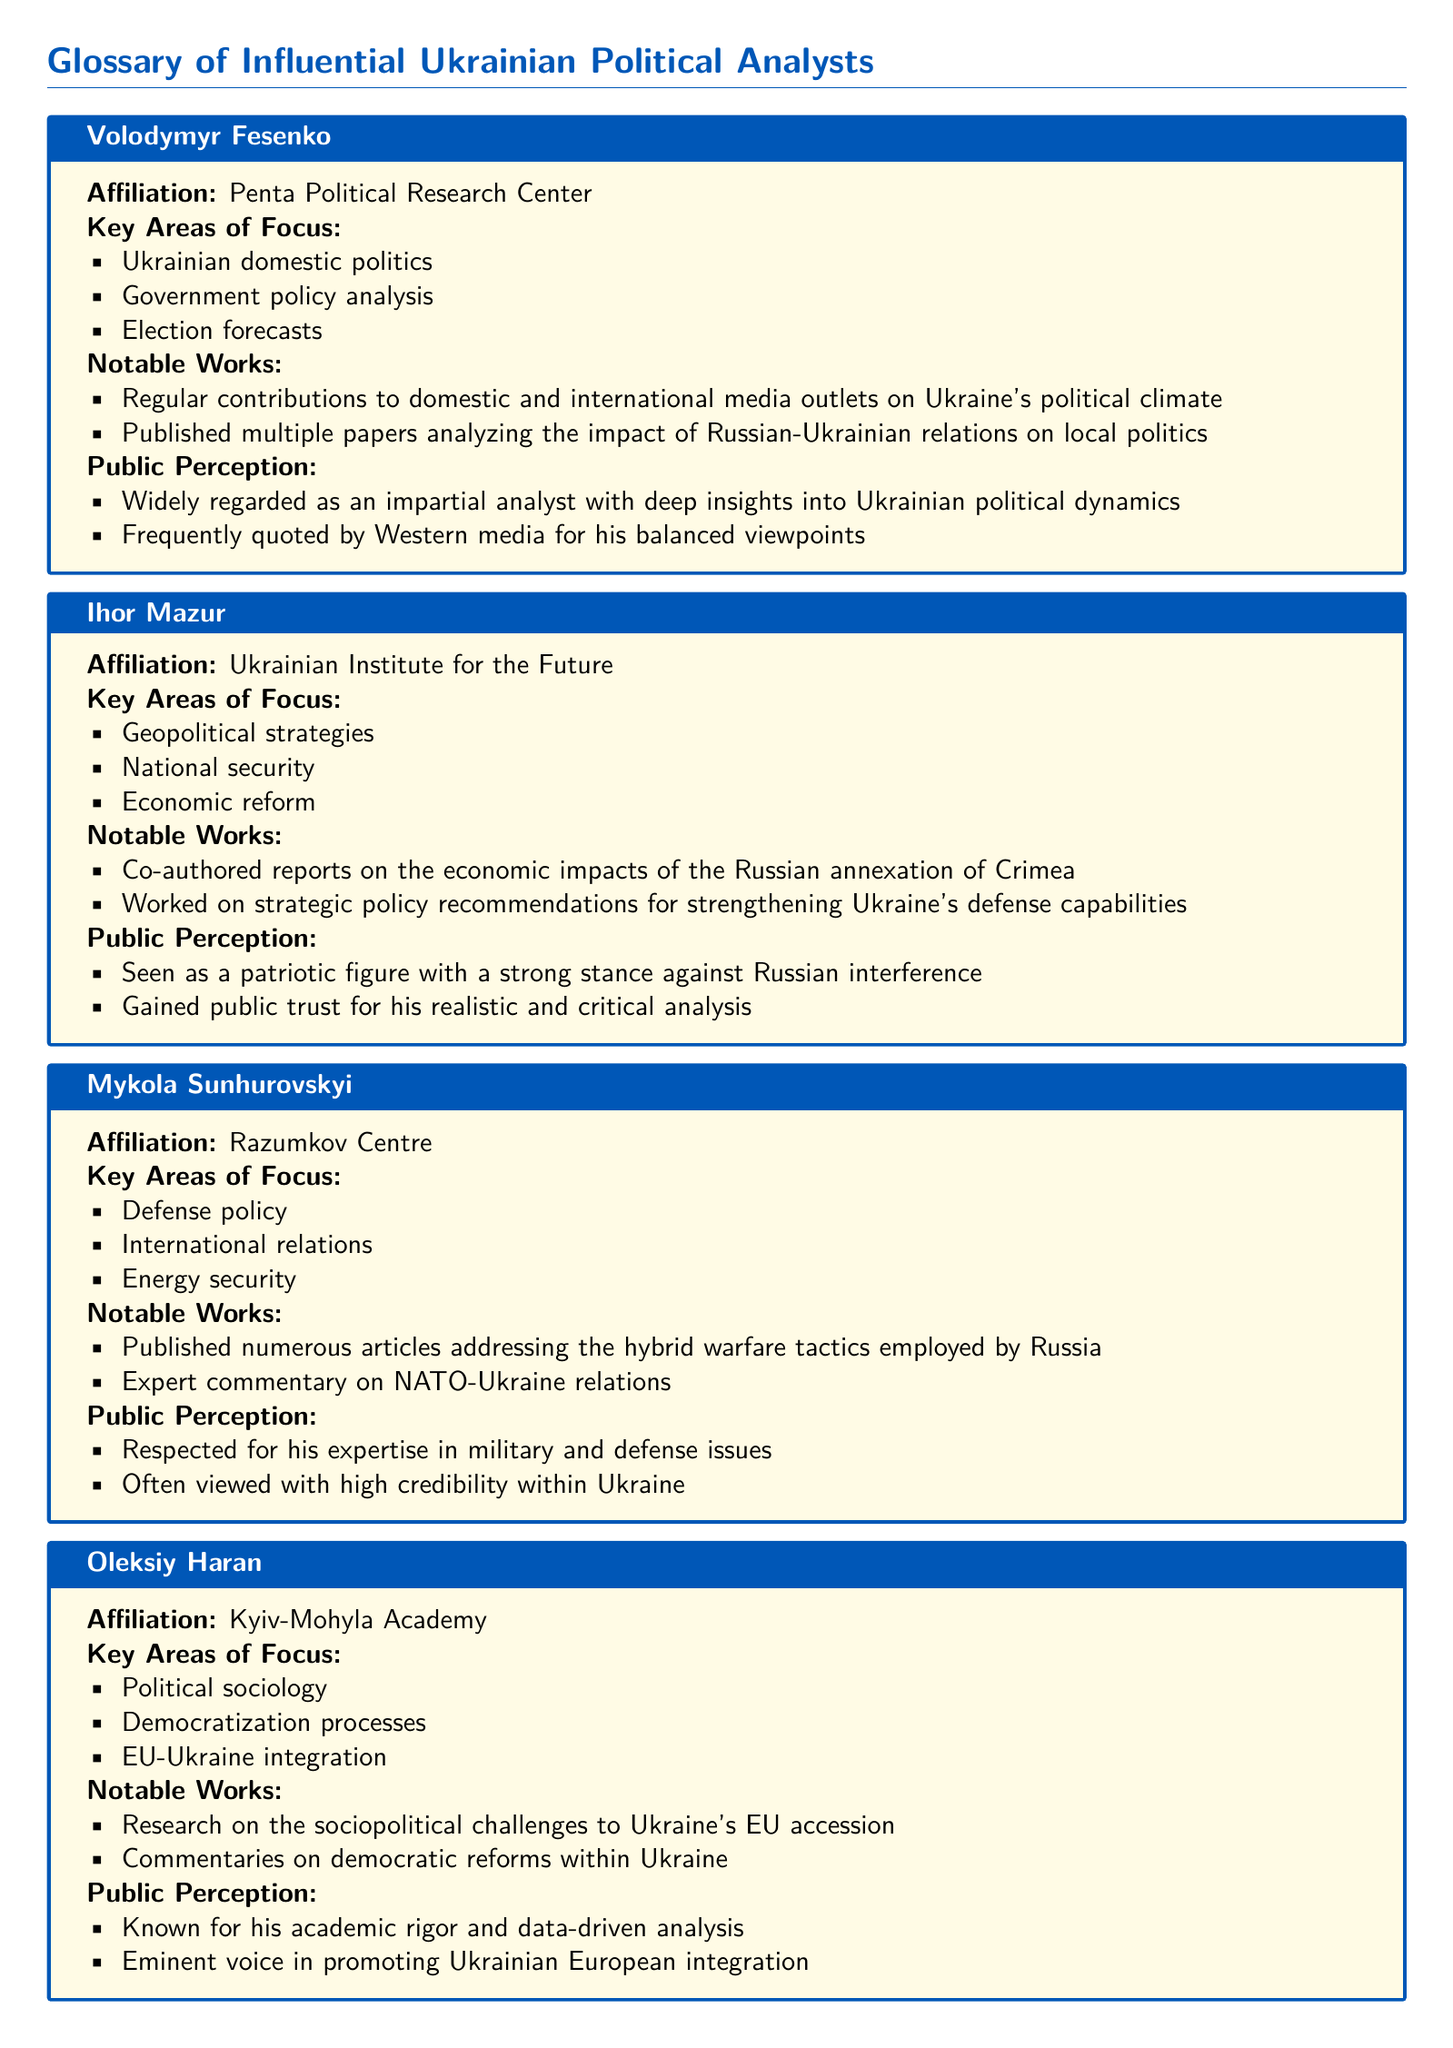What is Mikhail Borisovich Pogrebinsky's affiliation? His affiliation is mentioned in the document as Kyiv Center of Political Studies and Conflictology.
Answer: Kyiv Center of Political Studies and Conflictology What key area of focus is associated with Ihor Mazur? The document lists his key areas of focus, one of which is national security.
Answer: National security Which analyst is known for their work on EU-Ukraine integration? The document highlights Oleksiy Haran's focus areas, one of which is EU-Ukraine integration.
Answer: Oleksiy Haran What notable work is linked to Volodymyr Fesenko? The document states that he has published multiple papers analyzing the impact of Russian-Ukrainian relations on local politics.
Answer: Multiple papers analyzing the impact of Russian-Ukrainian relations on local politics What is the public perception of Mikhail Borisovich Pogrebinsky? The document mentions that he is criticized by many Ukrainians for his perceived pro-Russian bias.
Answer: Criticized for his perceived pro-Russian bias How is Tetiana Sydorchuk regarded in terms of European affairs? She is highly regarded for her in-depth knowledge of European affairs, according to the document.
Answer: Highly regarded What aspect of military issues does Mykola Sunhurovskyi focus on? The document specifies that he focuses on defense policy.
Answer: Defense policy Who frequently contributes to international media outlets? The document notes that Volodymyr Fesenko makes regular contributions to domestic and international media.
Answer: Volodymyr Fesenko What are the notable works of Ihor Mazur? The document cites that he co-authored reports on the economic impacts of the Russian annexation of Crimea.
Answer: Co-authored reports on the economic impacts of the Russian annexation of Crimea 